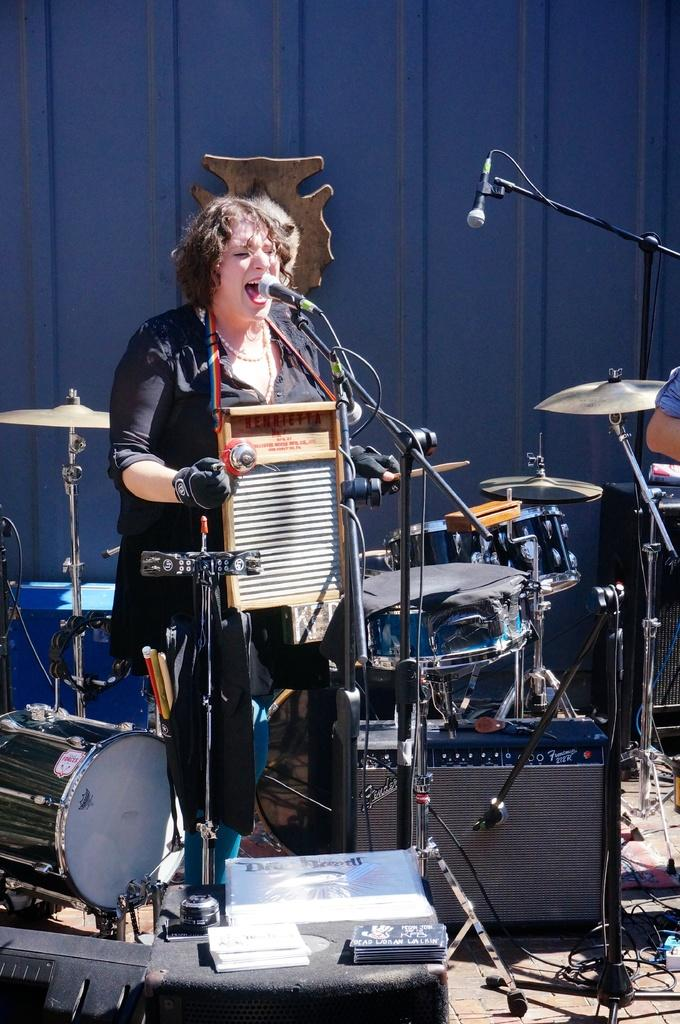What is the woman in the image doing? The woman is playing a musical instrument and singing. What object is the woman using to amplify her voice? There is a microphone in the image. What other musical instruments can be seen in the image? There are other musical instruments in the image. What type of plastic knot is being used by the boy in the image? There is no boy or plastic knot present in the image. 